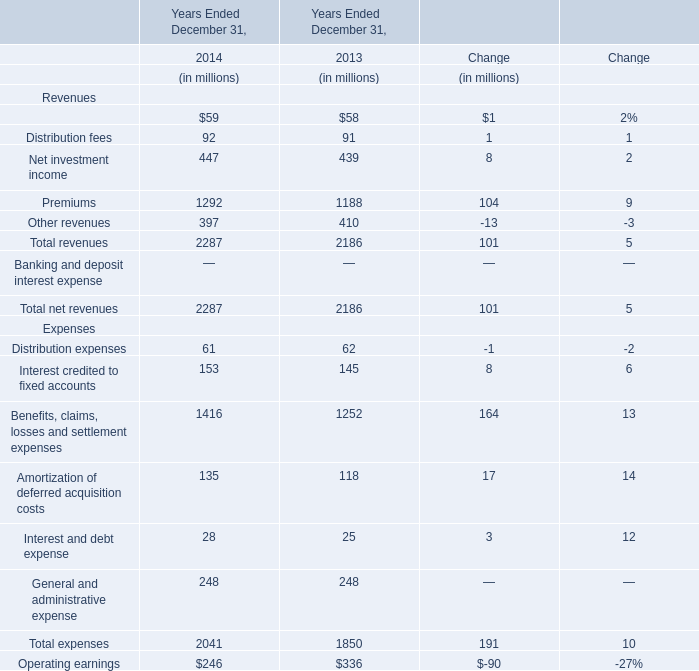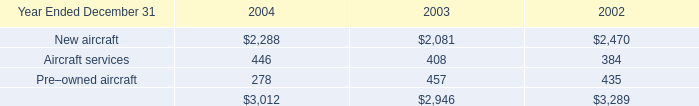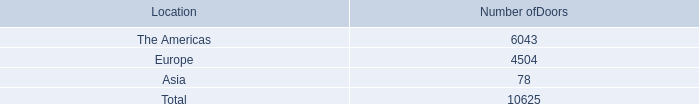In the year with largest amount of Premiums in table 0, what's the sum of Expenses in table 0? (in dollars in millions) 
Answer: 2041. 